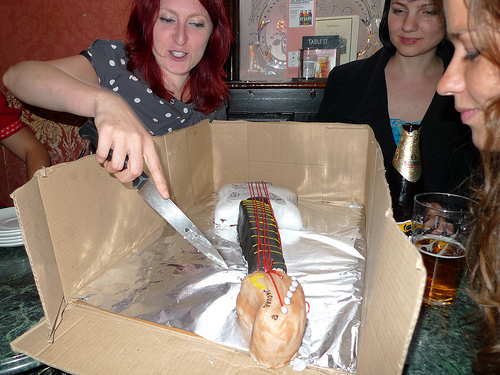<image>
Can you confirm if the knife is in the cake? No. The knife is not contained within the cake. These objects have a different spatial relationship. 